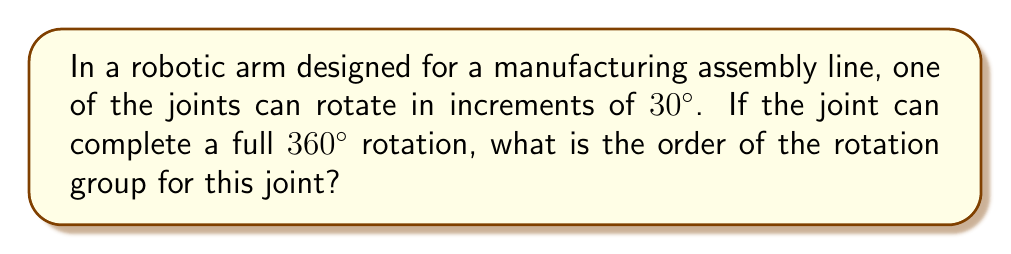Help me with this question. Let's approach this step-by-step:

1) First, we need to understand what the order of a rotation group means. The order of a group is the number of elements in the group.

2) In this case, we're dealing with a cyclic group of rotations. Each rotation is an element of the group.

3) We need to find how many distinct rotations we can have before we return to the starting position (identity element).

4) The joint rotates in increments of 30°. Let's list out the possible rotations:
   0° (identity), 30°, 60°, 90°, 120°, 150°, 180°, 210°, 240°, 270°, 300°, 330°

5) After 330°, the next 30° rotation brings us back to 0°, completing the cycle.

6) To calculate this mathematically:
   $$\text{Number of rotations} = \frac{\text{Full rotation}}{\text{Increment}} = \frac{360°}{30°} = 12$$

7) This means there are 12 distinct rotations (including the identity rotation of 0°) before the cycle repeats.

8) In group theory terms, this forms a cyclic group of order 12, often denoted as $C_{12}$ or $\mathbb{Z}_{12}$.

Therefore, the order of the rotation group for this robotic arm joint is 12.
Answer: The order of the rotation group is 12. 